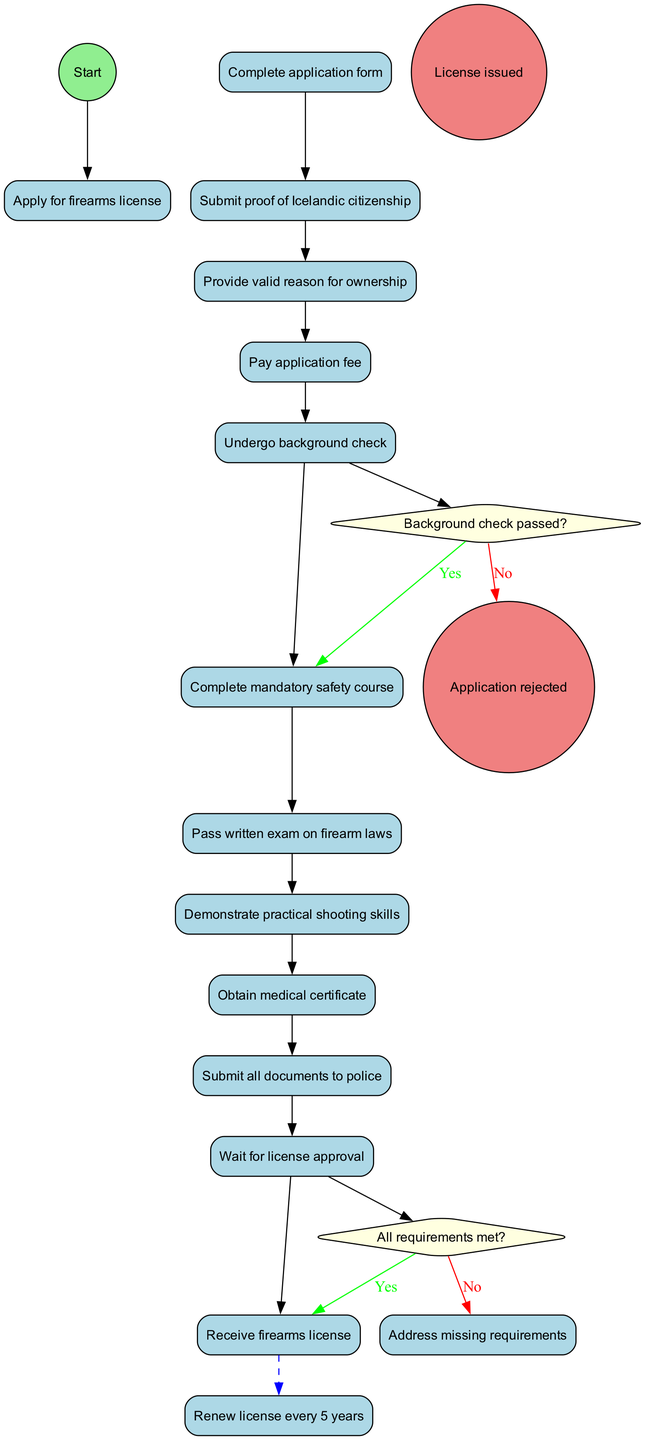What is the start node of the diagram? The start node is explicitly labeled as "Apply for firearms license." This can be found at the beginning of the activity flow, leading from the start circle.
Answer: Apply for firearms license How many activities are listed in the diagram? The diagram includes a total of 11 activities which are listed sequentially as steps in the process. Counting each unique activity confirms this total.
Answer: 11 What happens if the background check does not pass? According to the decision labeled "Background check passed?", if the answer is "No," the process leads to the node "Application rejected." This is a direct outcome of this specific decision.
Answer: Application rejected What is the final node in the workflow if all requirements are met? The final node is labeled "Receive firearms license." This is reached after all conditions in the decision node are fulfilled positively.
Answer: Receive firearms license What is the relationship between "Receive firearms license" and "Renew license every 5 years"? There is a dashed edge that connects "Receive firearms license" to "Renew license every 5 years," indicating that after obtaining the license, the next step involves renewal after a specified period.
Answer: Renew license every 5 years What should be done after the application is rejected? The flow indicates that one would need to "Address missing requirements" as a course of action after the application is rejected. This is indicated in a decision branch linked to the rejection.
Answer: Address missing requirements What must be submitted along with the application form? The application requires "Submit proof of Icelandic citizenship," which is one of the activities that occurs immediately after completing the application form.
Answer: Submit proof of Icelandic citizenship How many decision nodes are present in the diagram? There are 2 decision nodes present in the workflow, which direct the flow based on different conditions regarding the process status at key points.
Answer: 2 